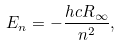<formula> <loc_0><loc_0><loc_500><loc_500>E _ { n } = - { \frac { h c R _ { \infty } } { n ^ { 2 } } } ,</formula> 